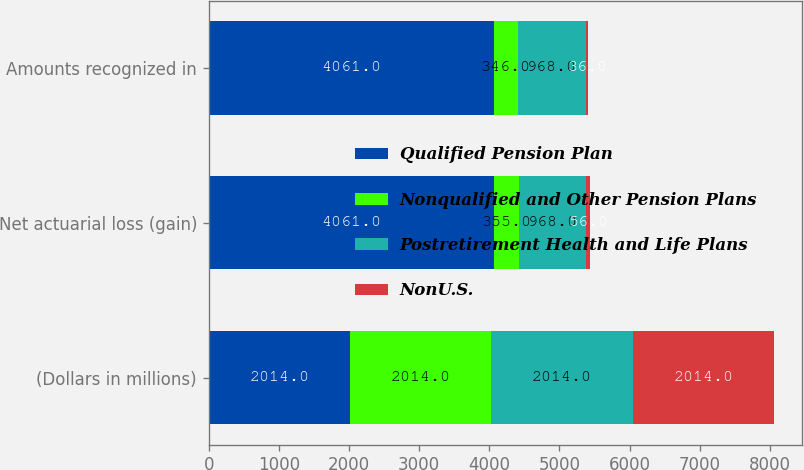Convert chart to OTSL. <chart><loc_0><loc_0><loc_500><loc_500><stacked_bar_chart><ecel><fcel>(Dollars in millions)<fcel>Net actuarial loss (gain)<fcel>Amounts recognized in<nl><fcel>Qualified Pension Plan<fcel>2014<fcel>4061<fcel>4061<nl><fcel>Nonqualified and Other Pension Plans<fcel>2014<fcel>355<fcel>346<nl><fcel>Postretirement Health and Life Plans<fcel>2014<fcel>968<fcel>968<nl><fcel>NonU.S.<fcel>2014<fcel>56<fcel>36<nl></chart> 